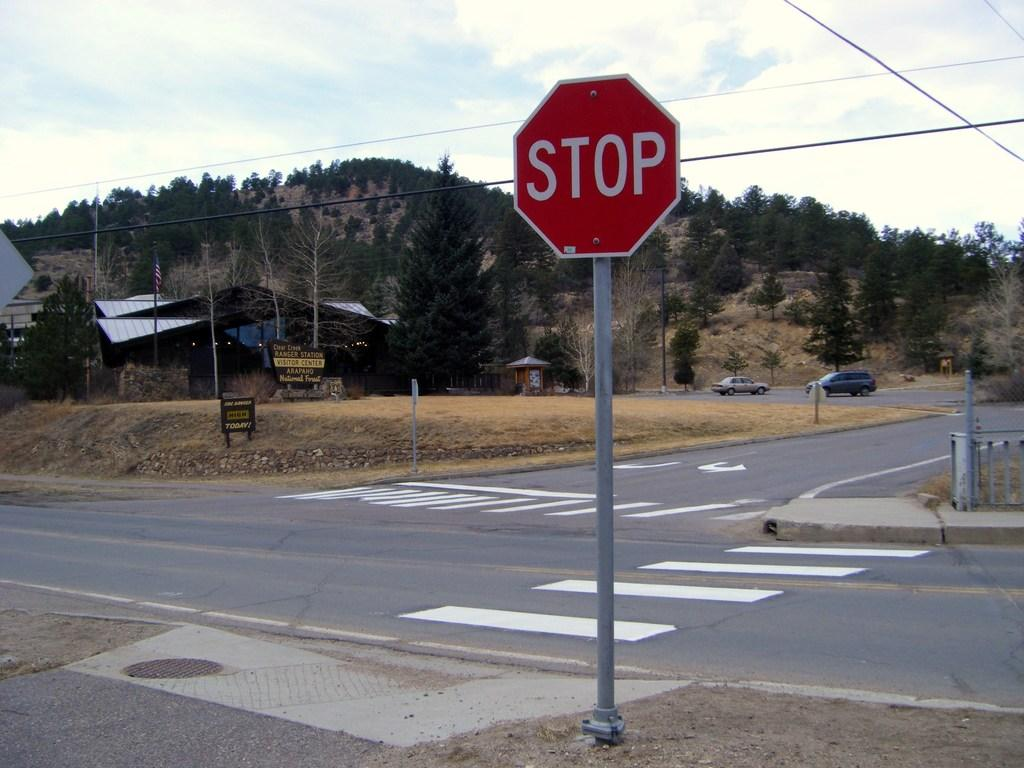<image>
Render a clear and concise summary of the photo. A stop sign might be in the wrong place at a 3 way intersection. 